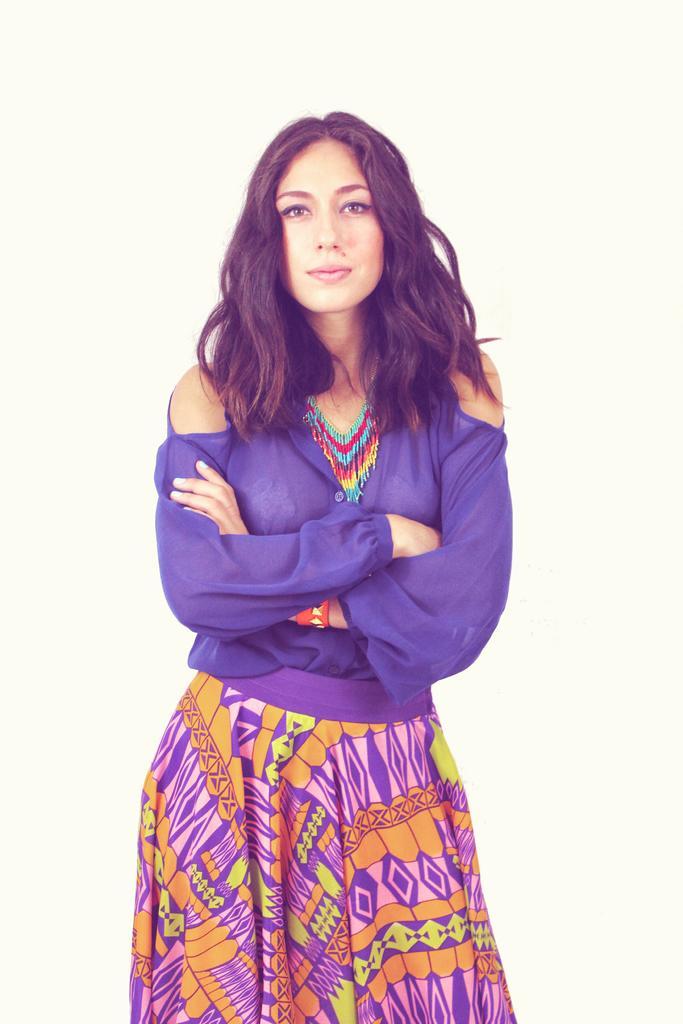Describe this image in one or two sentences. In the picture I can see a woman wearing purple color dress, skirt and necklace is standing. The background of the image is in white color. 